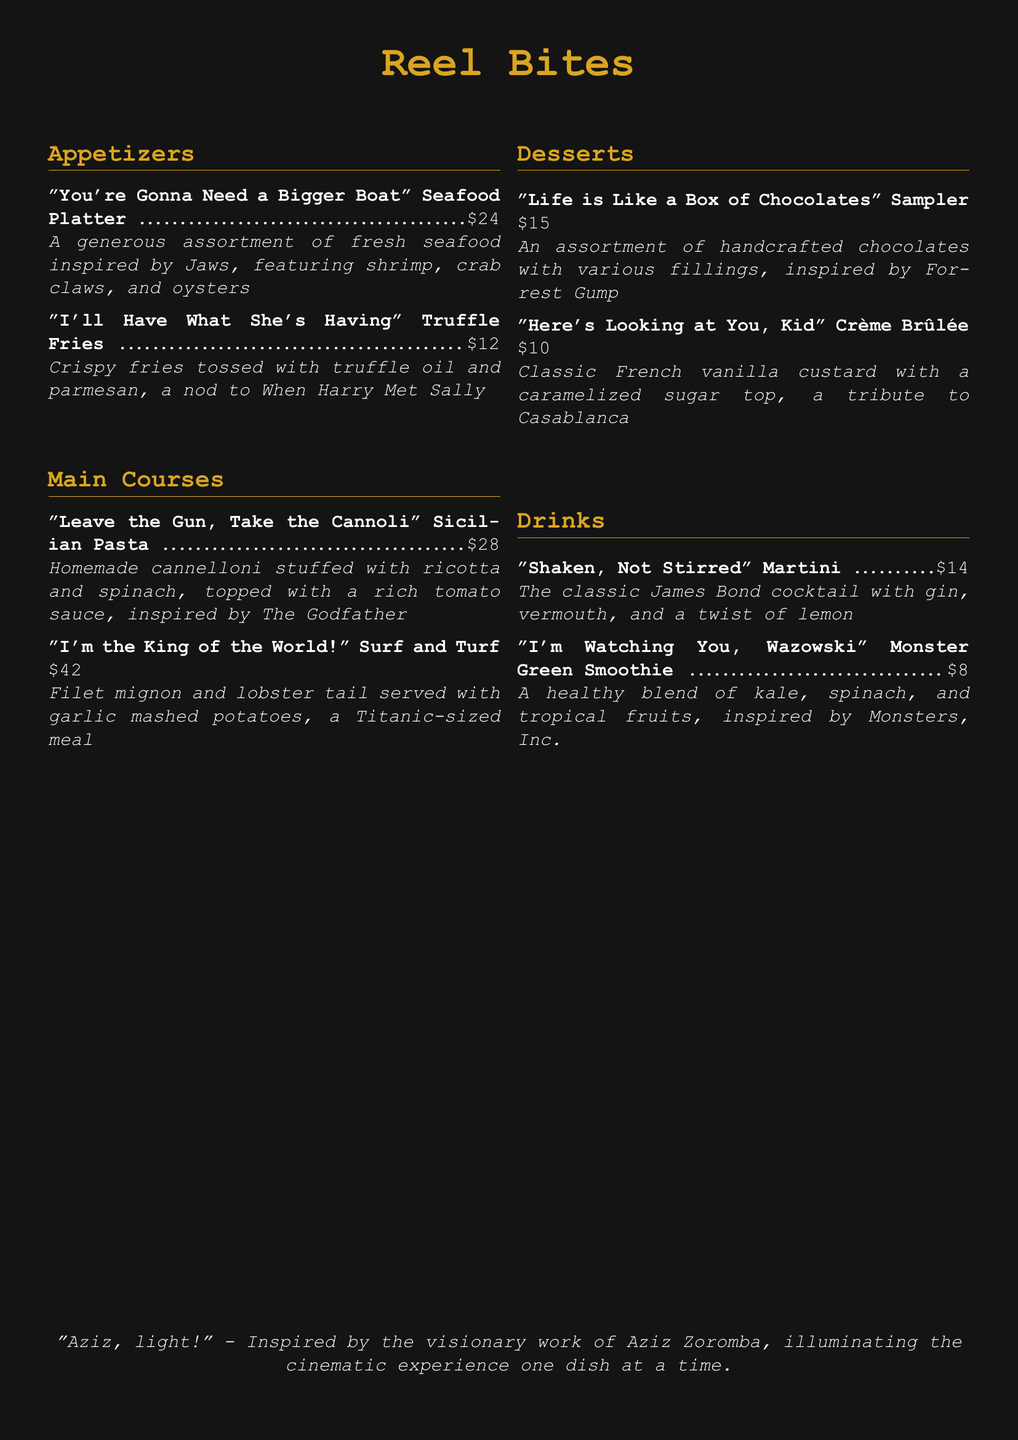What is the name of the seafood platter? The seafood platter is inspired by Jaws and is called "You're Gonna Need a Bigger Boat."
Answer: "You're Gonna Need a Bigger Boat" How much do the truffle fries cost? The truffle fries, listed under appetizers, cost $12.
Answer: $12 Which movie inspired the crème brûlée dessert? The crème brûlée is a tribute to Casablanca.
Answer: Casablanca What are the main ingredients in the Surf and Turf dish? The Surf and Turf dish includes filet mignon and lobster tail.
Answer: Filet mignon and lobster tail What drink is described as "Shaken, Not Stirred"? The drink referred to as "Shaken, Not Stirred" is a martini.
Answer: Martini How many appetizers are listed on the menu? There are two appetizers listed in the document.
Answer: 2 What dessert is inspired by Forrest Gump? The dessert inspired by Forrest Gump is the chocolate sampler.
Answer: Sampler What is the price of the Sicilian Pasta? The Sicilian Pasta is priced at $28.
Answer: $28 Which item is inspired by Monsters, Inc.? The drink inspired by Monsters, Inc. is the Monster Green Smoothie.
Answer: Monster Green Smoothie 